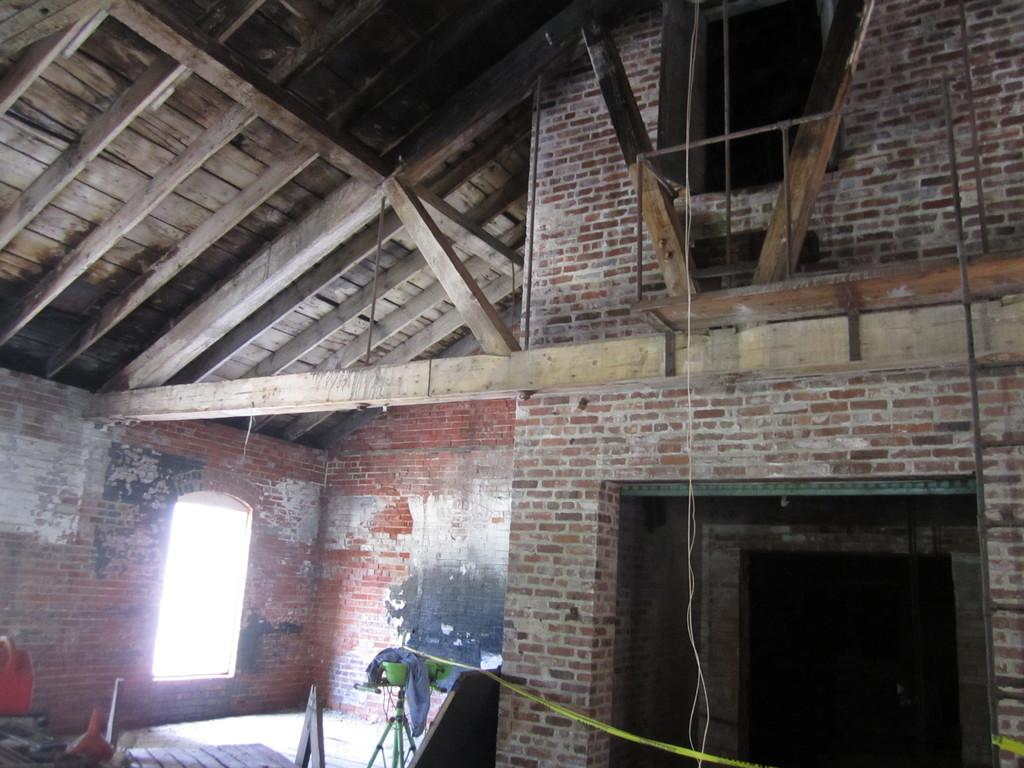What architectural feature is visible in the image? There is a window and a roof visible in the image. What type of material is used for the walls in the image? The walls in the image are made of bricks. Can you describe the unspecified "things" in the image? Unfortunately, the provided facts do not give any details about the "things" in the image, so we cannot describe them. What type of can is depicted in the image? There is no can present in the image. What religious symbols can be seen in the image? There is no information about religious symbols in the provided facts, so we cannot determine if any are present in the image. 